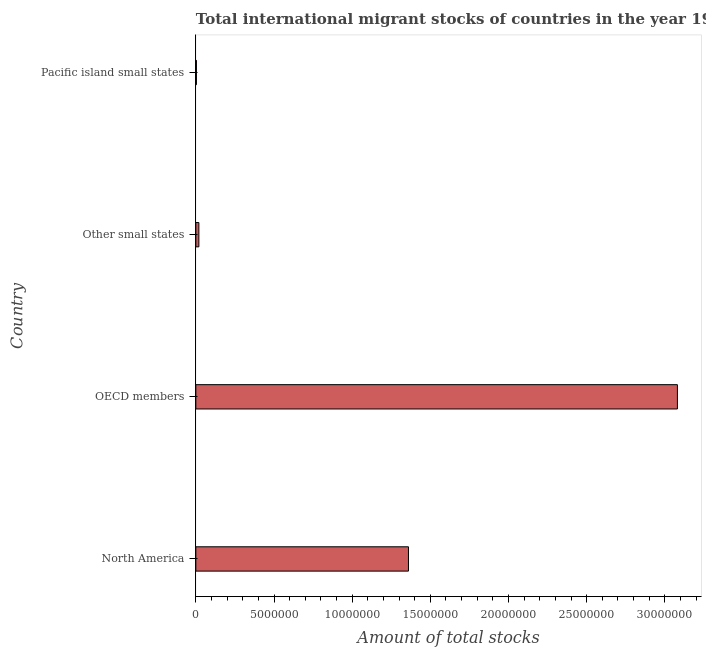Does the graph contain grids?
Your response must be concise. No. What is the title of the graph?
Give a very brief answer. Total international migrant stocks of countries in the year 1960. What is the label or title of the X-axis?
Offer a terse response. Amount of total stocks. What is the label or title of the Y-axis?
Keep it short and to the point. Country. What is the total number of international migrant stock in OECD members?
Provide a short and direct response. 3.08e+07. Across all countries, what is the maximum total number of international migrant stock?
Your answer should be very brief. 3.08e+07. Across all countries, what is the minimum total number of international migrant stock?
Give a very brief answer. 3.82e+04. In which country was the total number of international migrant stock maximum?
Provide a short and direct response. OECD members. In which country was the total number of international migrant stock minimum?
Keep it short and to the point. Pacific island small states. What is the sum of the total number of international migrant stock?
Provide a short and direct response. 4.46e+07. What is the difference between the total number of international migrant stock in Other small states and Pacific island small states?
Offer a very short reply. 1.57e+05. What is the average total number of international migrant stock per country?
Provide a short and direct response. 1.12e+07. What is the median total number of international migrant stock?
Make the answer very short. 6.90e+06. What is the ratio of the total number of international migrant stock in North America to that in OECD members?
Provide a short and direct response. 0.44. What is the difference between the highest and the second highest total number of international migrant stock?
Make the answer very short. 1.72e+07. Is the sum of the total number of international migrant stock in North America and Other small states greater than the maximum total number of international migrant stock across all countries?
Keep it short and to the point. No. What is the difference between the highest and the lowest total number of international migrant stock?
Give a very brief answer. 3.08e+07. Are all the bars in the graph horizontal?
Ensure brevity in your answer.  Yes. What is the difference between two consecutive major ticks on the X-axis?
Offer a terse response. 5.00e+06. What is the Amount of total stocks in North America?
Provide a succinct answer. 1.36e+07. What is the Amount of total stocks in OECD members?
Ensure brevity in your answer.  3.08e+07. What is the Amount of total stocks in Other small states?
Your answer should be very brief. 1.95e+05. What is the Amount of total stocks of Pacific island small states?
Ensure brevity in your answer.  3.82e+04. What is the difference between the Amount of total stocks in North America and OECD members?
Make the answer very short. -1.72e+07. What is the difference between the Amount of total stocks in North America and Other small states?
Your answer should be very brief. 1.34e+07. What is the difference between the Amount of total stocks in North America and Pacific island small states?
Offer a terse response. 1.36e+07. What is the difference between the Amount of total stocks in OECD members and Other small states?
Keep it short and to the point. 3.06e+07. What is the difference between the Amount of total stocks in OECD members and Pacific island small states?
Offer a very short reply. 3.08e+07. What is the difference between the Amount of total stocks in Other small states and Pacific island small states?
Offer a terse response. 1.57e+05. What is the ratio of the Amount of total stocks in North America to that in OECD members?
Give a very brief answer. 0.44. What is the ratio of the Amount of total stocks in North America to that in Other small states?
Provide a short and direct response. 69.79. What is the ratio of the Amount of total stocks in North America to that in Pacific island small states?
Offer a very short reply. 356.32. What is the ratio of the Amount of total stocks in OECD members to that in Other small states?
Provide a succinct answer. 158.07. What is the ratio of the Amount of total stocks in OECD members to that in Pacific island small states?
Provide a succinct answer. 806.98. What is the ratio of the Amount of total stocks in Other small states to that in Pacific island small states?
Provide a succinct answer. 5.11. 